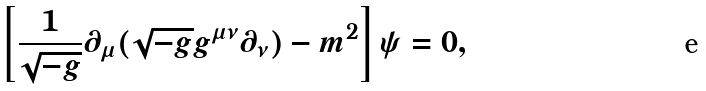Convert formula to latex. <formula><loc_0><loc_0><loc_500><loc_500>\left [ \frac { 1 } { \sqrt { - g } } \partial _ { \mu } ( \sqrt { - g } g ^ { \mu \nu } \partial _ { \nu } ) - m ^ { 2 } \right ] \psi = 0 ,</formula> 